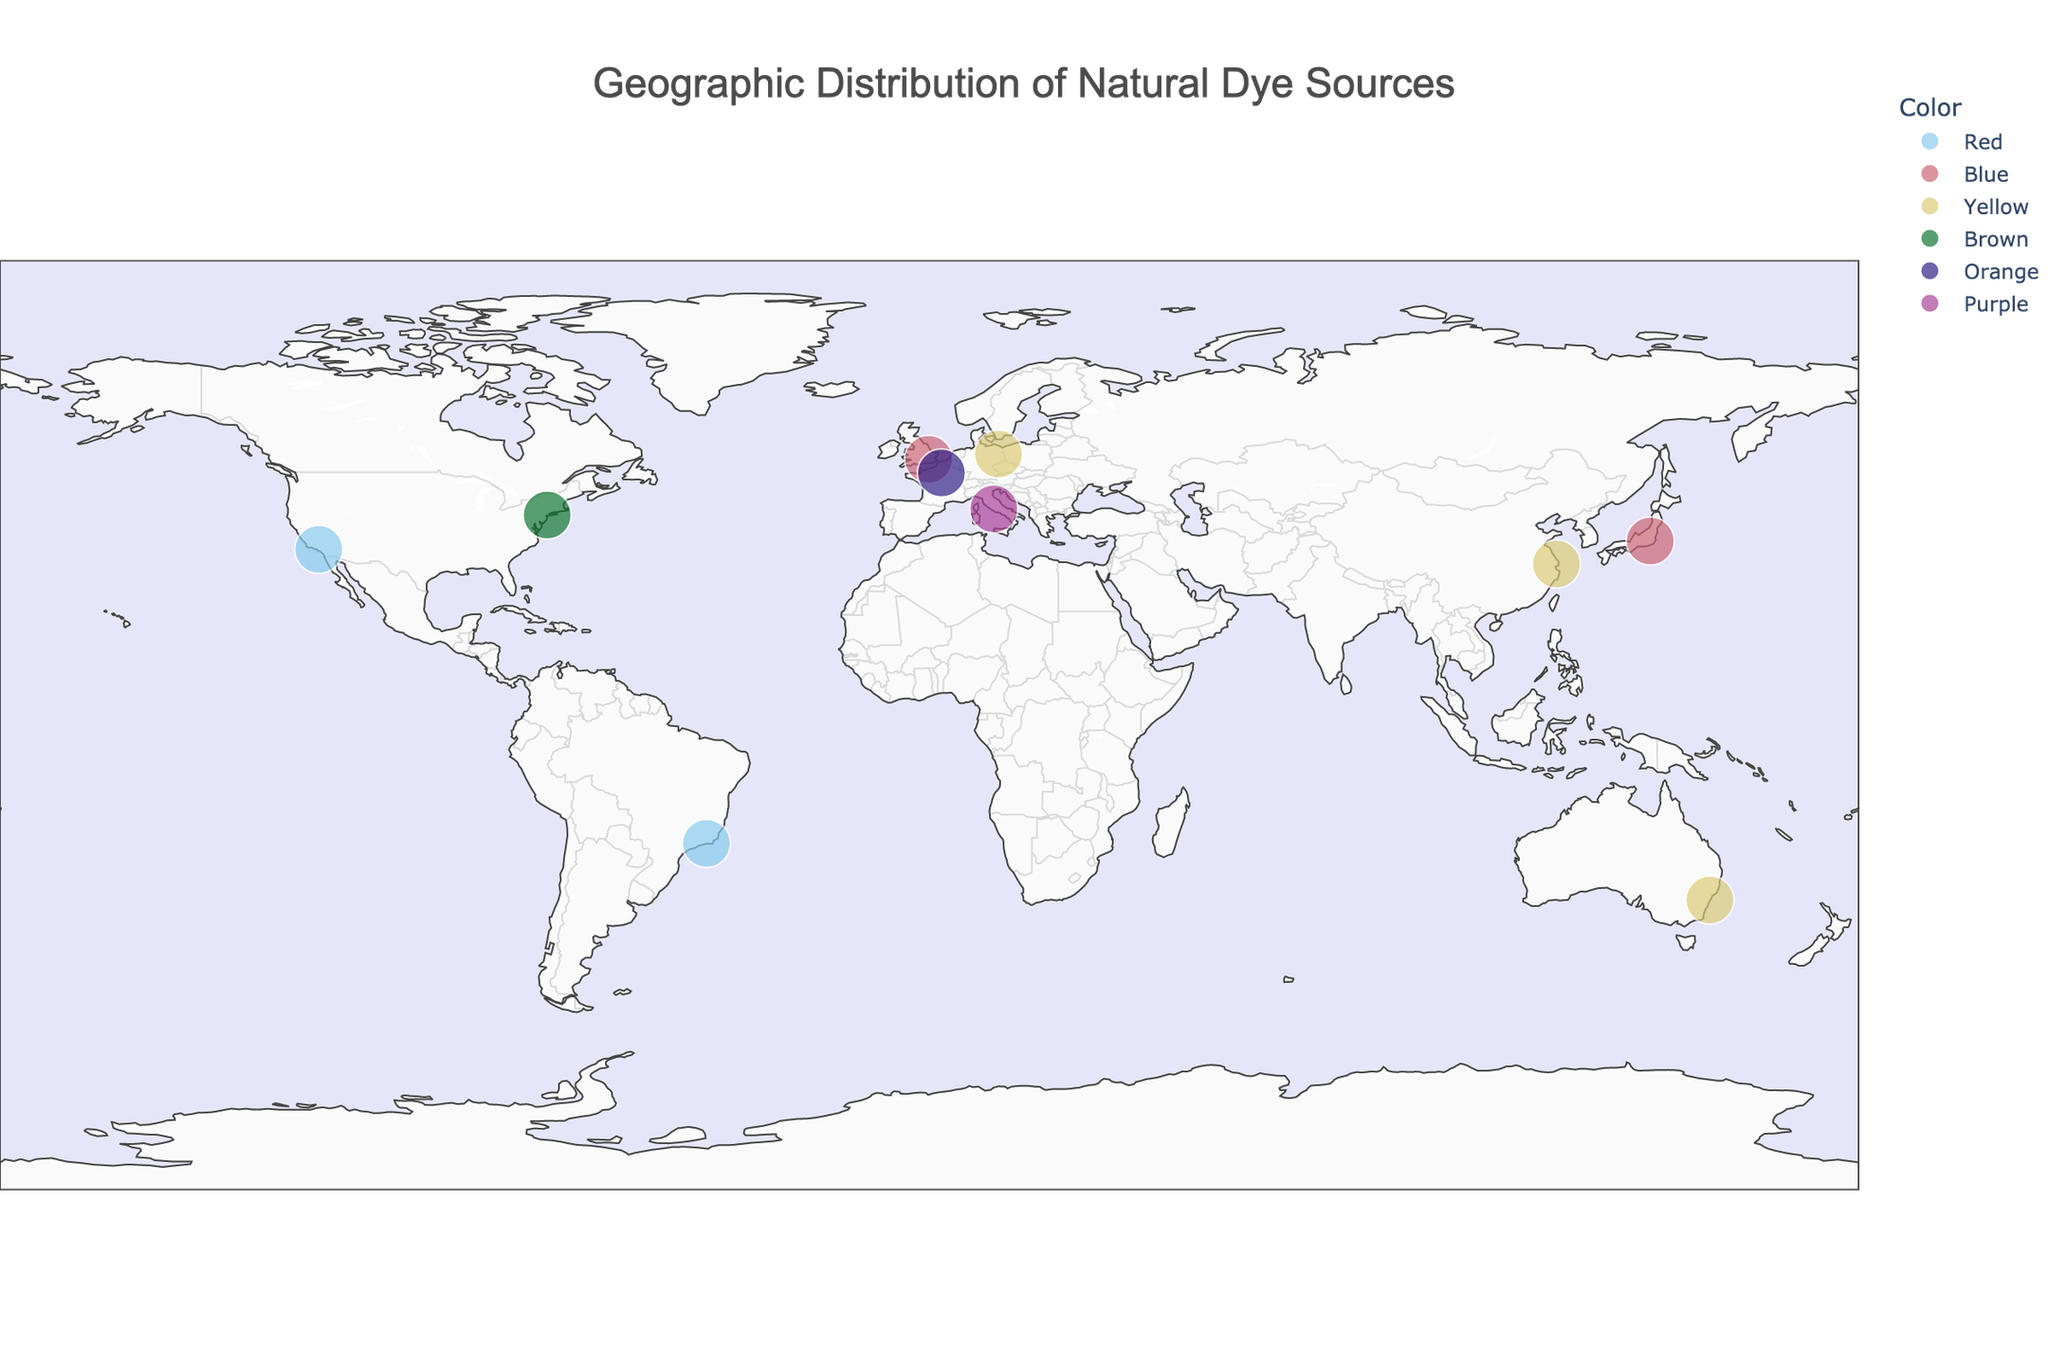What is the title of the map? The title of the map is usually placed at the top center. By looking at the top of the figure, the title reads "Geographic Distribution of Natural Dye Sources".
Answer: Geographic Distribution of Natural Dye Sources How many dye sources are represented on the map? Each dye source is marked with a distinct point on the map. Counting these points will give us the number of dye sources represented. There are 10 points on the map.
Answer: 10 Which dye source is used in Japanese Kimono and what color is it associated with? By referring to the hover data, we can find that the dye source used in Japanese Kimono is Indigo, which is associated with the color blue.
Answer: Indigo, Blue What are the coordinates for the dye source Black Walnut? By hovering over the relevant point or checking the data, we find that Black Walnut is located at latitude 40.7128 and longitude -74.0060.
Answer: 40.7128, -74.0060 Which continent has the highest number of natural dye sources represented on the map? By examining the geographic distribution of the points across continents, Europe seems to have the highest number of points (3 points corresponding to Woad, Madder Root, and Weld).
Answer: Europe How many dye sources are associated with the color yellow? By referring to the hover data on the figure, we see that Eucalyptus, Pagoda Tree Buds, and Weld are associated with yellow.
Answer: 3 Which dye source corresponds to the partner's description "Warm golden hue"? By checking the hover data for each point, Eucalyptus has the description "Warm golden hue".
Answer: Eucalyptus Compare the latitudes of the dye sources used in Oaxacan Textiles and Roman Togas. Which one is further north? Oaxacan Textiles (Cochineal) is at latitude 34.0522, and Roman Togas (Tyrian Purple) is at latitude 41.9028. Since 41.9028 is greater than 34.0522, Roman Togas is further north.
Answer: Roman Togas What is the common color associated with both Scottish Tartans and Japanese Kimono? By looking at the hover data for both points, we see that the common color is blue.
Answer: Blue Calculate the average latitude of the dye sources located in the Southern Hemisphere. The dye sources in the Southern Hemisphere are Eucalyptus (latitude -33.8688) and Brazilwood (latitude -22.9068). The average latitude is calculated as (-33.8688 + -22.9068) / 2 = -28.3878.
Answer: -28.3878 